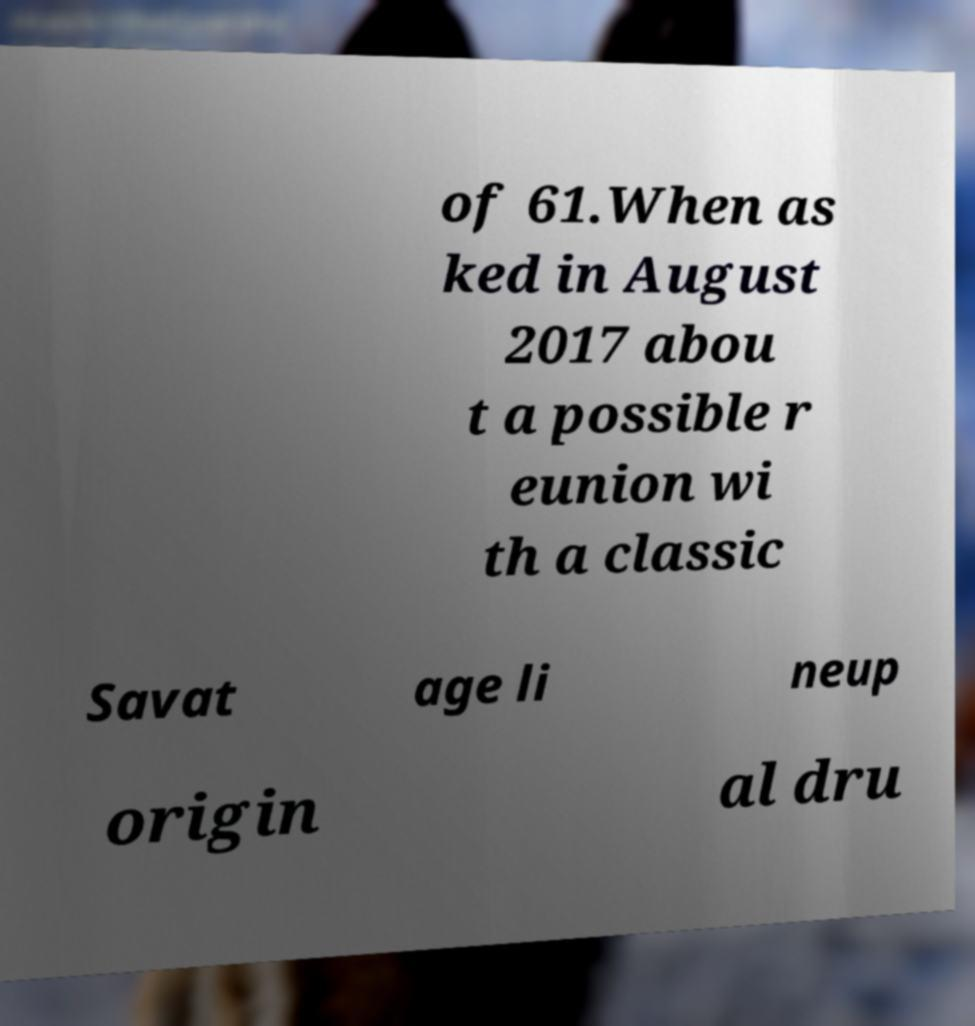Can you accurately transcribe the text from the provided image for me? of 61.When as ked in August 2017 abou t a possible r eunion wi th a classic Savat age li neup origin al dru 